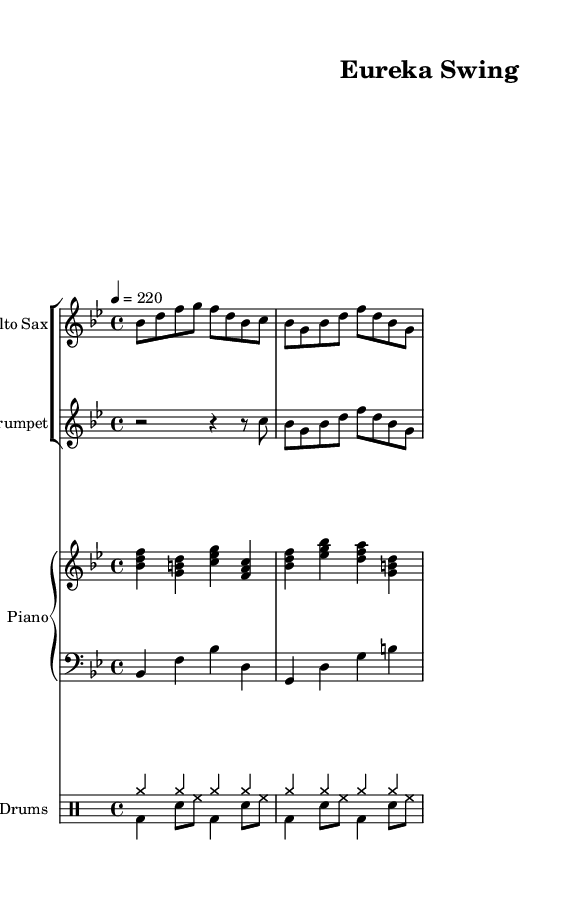What is the key signature of this music? The key signature is B-flat major, indicated by the presence of two flats (B-flat and E-flat) at the beginning of the staff.
Answer: B-flat major What is the time signature of this piece? The time signature is 4/4, which is indicated at the beginning of the staff and shows that there are four beats in a measure.
Answer: 4/4 What is the tempo marking for this piece? The tempo marking is 220 beats per minute, shown in the tempo directive that specifies "4 = 220".
Answer: 220 Which instruments are included in this ensemble? The ensemble consists of Alto Sax, Trumpet, Piano, Bass, and Drums, as specified by the instrument names in the respective staves.
Answer: Alto Sax, Trumpet, Piano, Bass, Drums What is the rhythmic value of the first note played by the Alto Sax? The first note played by the Alto Sax is an eighth note, represented by the "8" next to the note in the sheet music.
Answer: Eighth note How many measures are present in the Alto Sax part? The Alto Sax part contains four measures, as counted from the beginning to the end of the displayed music.
Answer: Four measures What jazz characteristic is highlighted in this piece? The piece showcases an upbeat swing feel, which is a common characteristic of bebop jazz, reflected in the lively tempo and syncopated rhythms.
Answer: Upbeat swing 